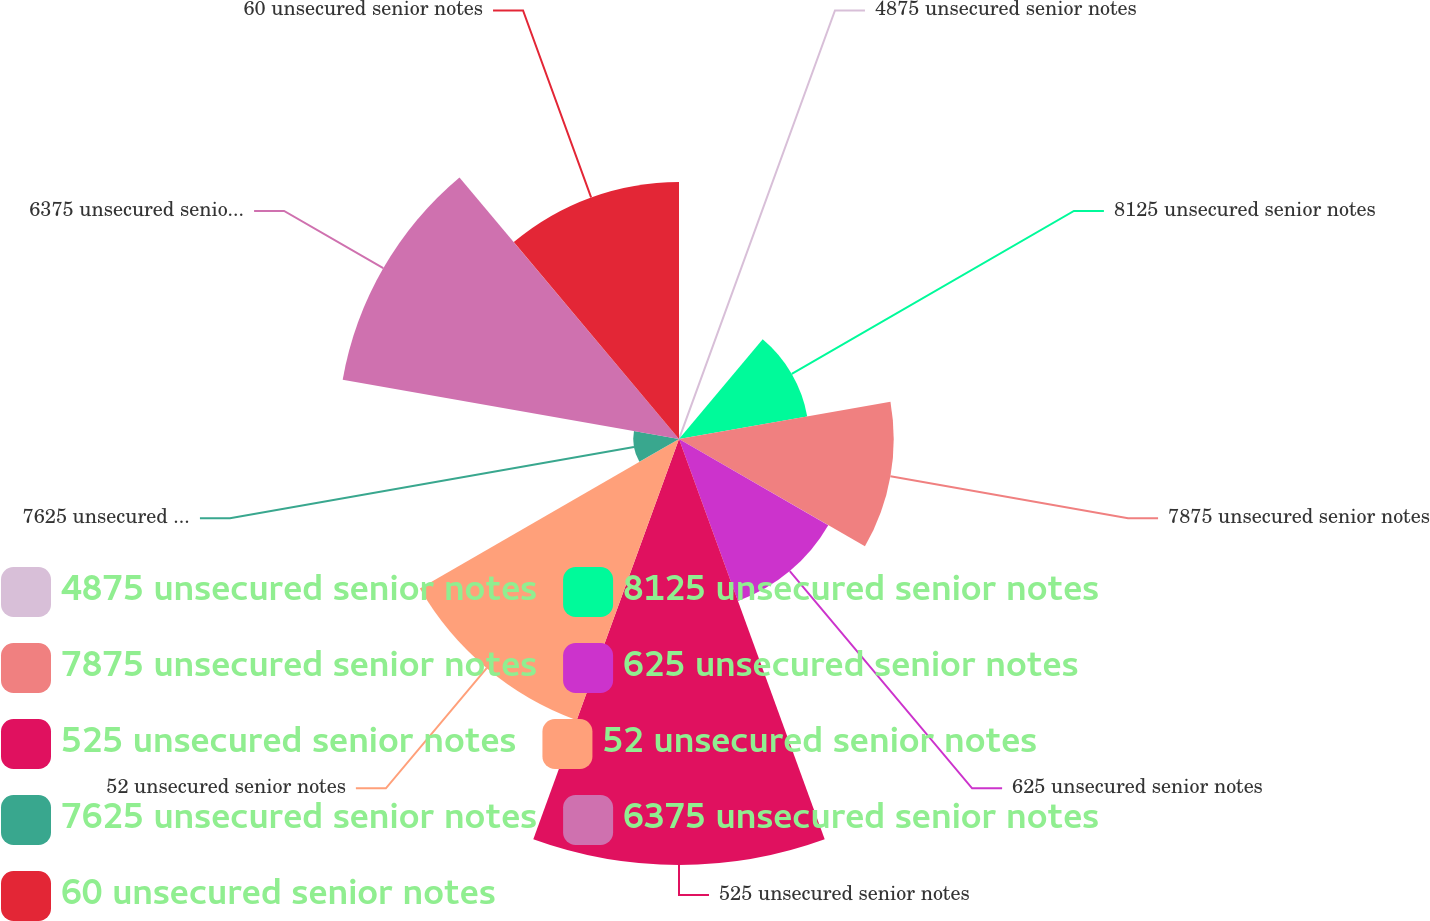Convert chart to OTSL. <chart><loc_0><loc_0><loc_500><loc_500><pie_chart><fcel>4875 unsecured senior notes<fcel>8125 unsecured senior notes<fcel>7875 unsecured senior notes<fcel>625 unsecured senior notes<fcel>525 unsecured senior notes<fcel>52 unsecured senior notes<fcel>7625 unsecured senior notes<fcel>6375 unsecured senior notes<fcel>60 unsecured senior notes<nl><fcel>0.18%<fcel>6.89%<fcel>11.36%<fcel>9.12%<fcel>22.54%<fcel>15.83%<fcel>2.42%<fcel>18.07%<fcel>13.6%<nl></chart> 